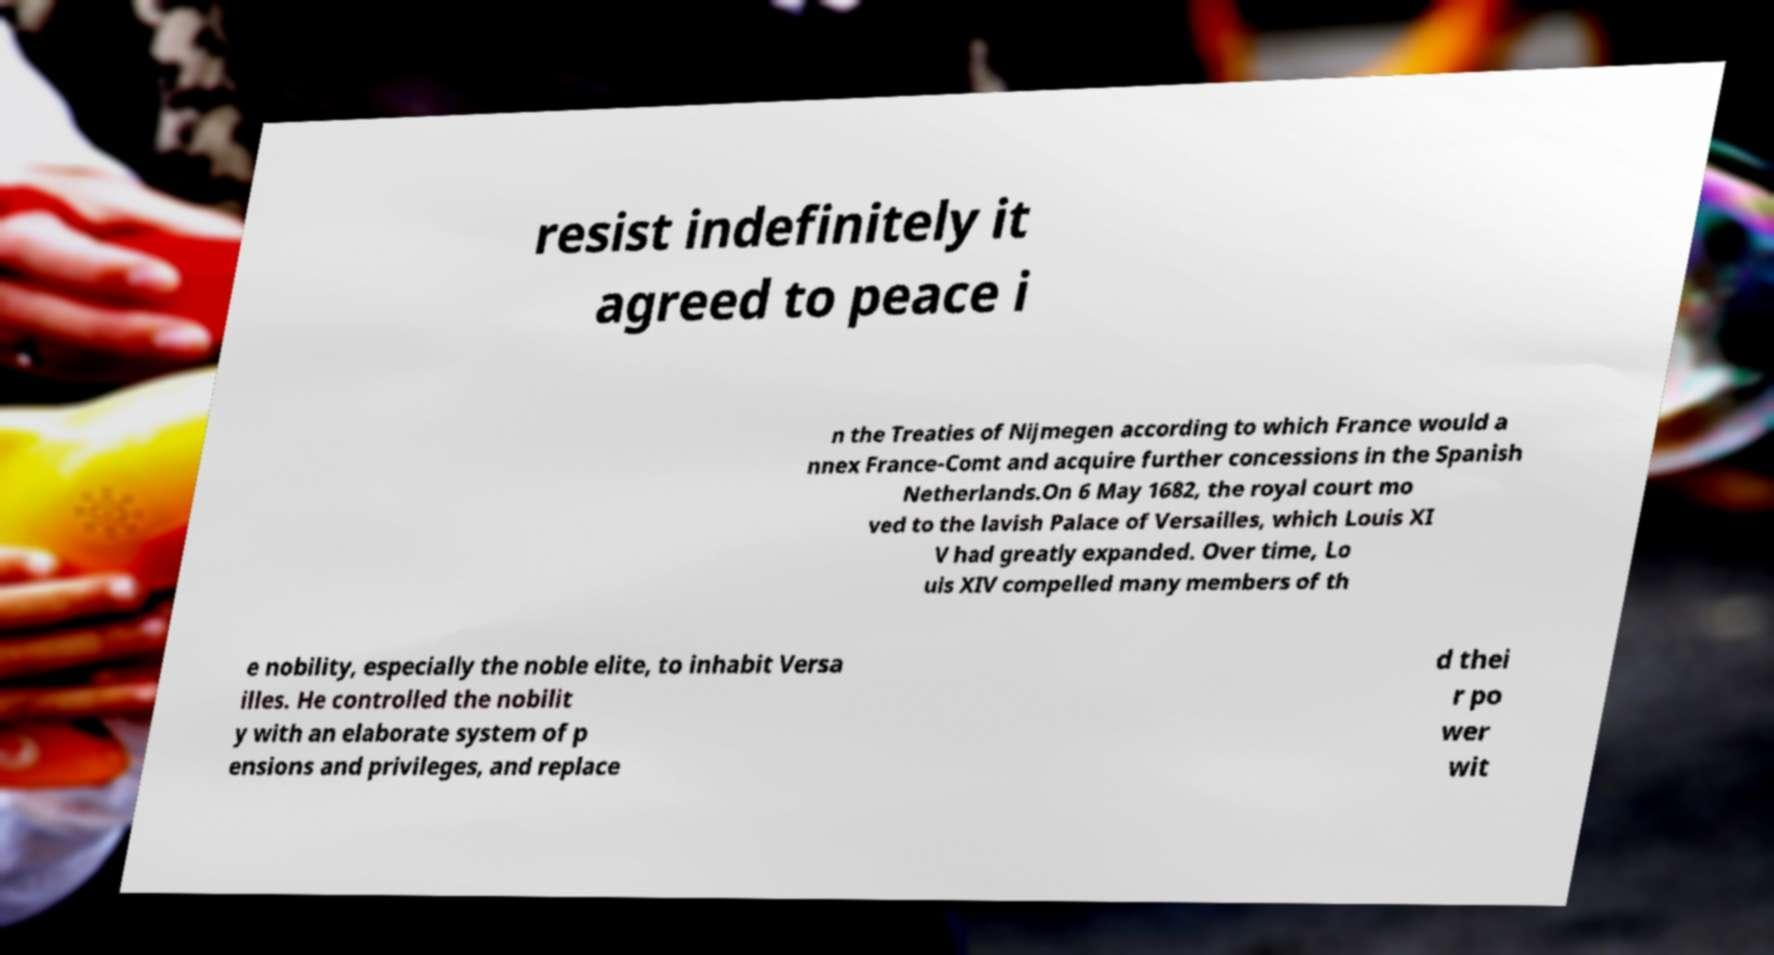Can you read and provide the text displayed in the image?This photo seems to have some interesting text. Can you extract and type it out for me? resist indefinitely it agreed to peace i n the Treaties of Nijmegen according to which France would a nnex France-Comt and acquire further concessions in the Spanish Netherlands.On 6 May 1682, the royal court mo ved to the lavish Palace of Versailles, which Louis XI V had greatly expanded. Over time, Lo uis XIV compelled many members of th e nobility, especially the noble elite, to inhabit Versa illes. He controlled the nobilit y with an elaborate system of p ensions and privileges, and replace d thei r po wer wit 